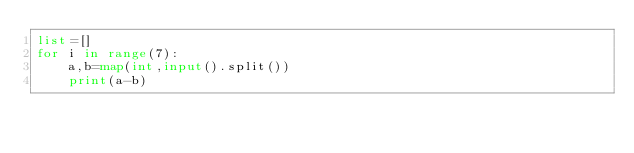<code> <loc_0><loc_0><loc_500><loc_500><_Python_>list=[]
for i in range(7):
    a,b=map(int,input().split())
    print(a-b)
</code> 